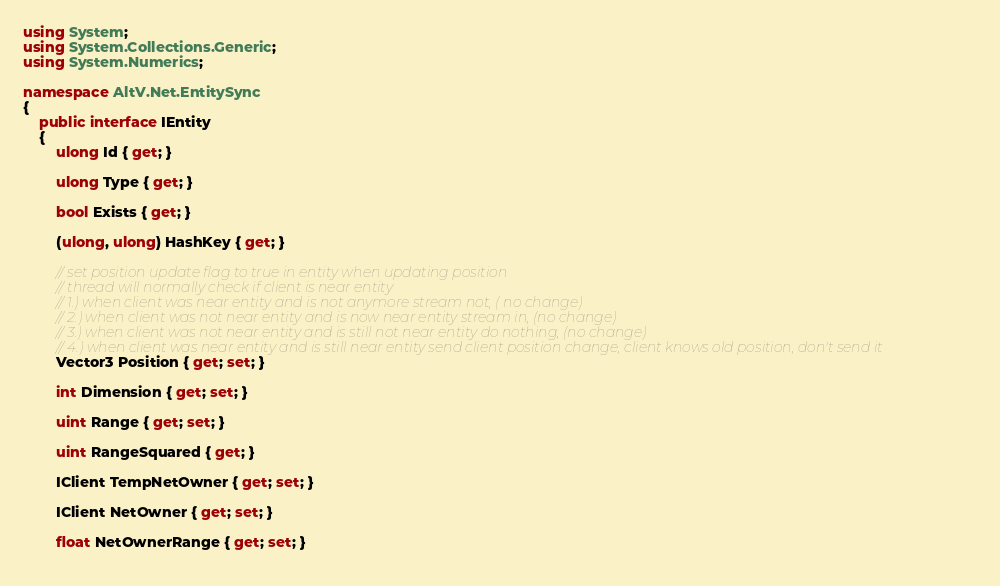Convert code to text. <code><loc_0><loc_0><loc_500><loc_500><_C#_>using System;
using System.Collections.Generic;
using System.Numerics;

namespace AltV.Net.EntitySync
{
    public interface IEntity
    {
        ulong Id { get; }

        ulong Type { get; }

        bool Exists { get; }

        (ulong, ulong) HashKey { get; }

        // set position update flag to true in entity when updating position
        // thread will normally check if client is near entity
        // 1.) when client was near entity and is not anymore stream not, ( no change)
        // 2.) when client was not near entity and is now near entity stream in, (no change)
        // 3.) when client was not near entity and is still not near entity do nothing, (no change)
        // 4.) when client was near entity and is still near entity send client position change, client knows old position, don't send it
        Vector3 Position { get; set; }

        int Dimension { get; set; }

        uint Range { get; set; }
        
        uint RangeSquared { get; }
        
        IClient TempNetOwner { get; set; }

        IClient NetOwner { get; set; }
        
        float NetOwnerRange { get; set; }
        </code> 